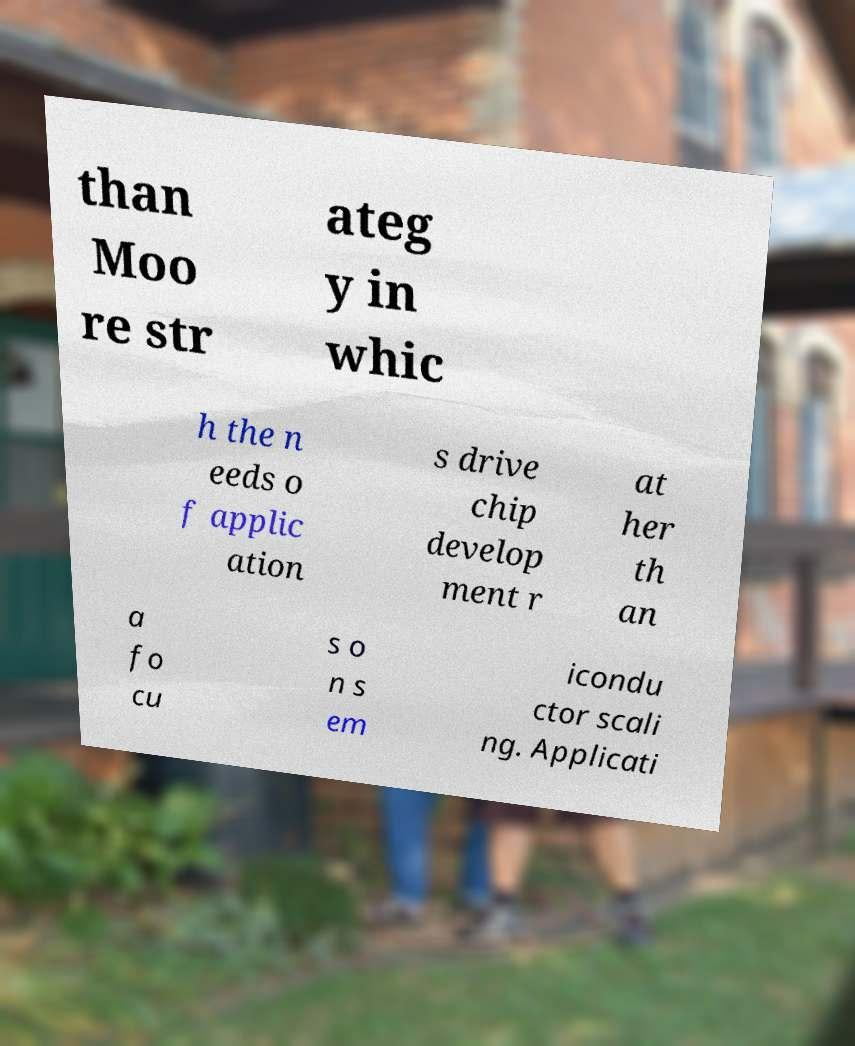Could you assist in decoding the text presented in this image and type it out clearly? than Moo re str ateg y in whic h the n eeds o f applic ation s drive chip develop ment r at her th an a fo cu s o n s em icondu ctor scali ng. Applicati 